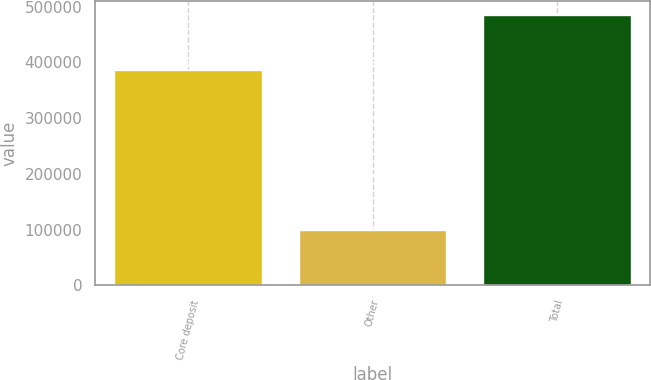Convert chart. <chart><loc_0><loc_0><loc_500><loc_500><bar_chart><fcel>Core deposit<fcel>Other<fcel>Total<nl><fcel>385725<fcel>99443<fcel>485168<nl></chart> 